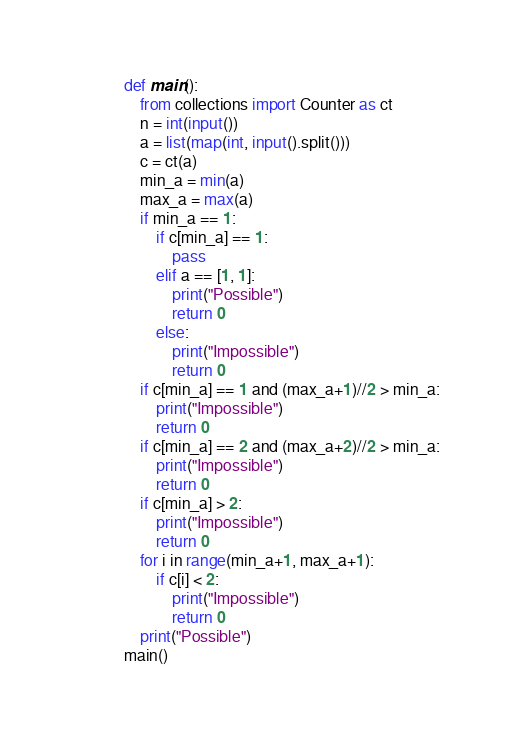Convert code to text. <code><loc_0><loc_0><loc_500><loc_500><_Python_>def main():
    from collections import Counter as ct
    n = int(input())
    a = list(map(int, input().split()))
    c = ct(a)
    min_a = min(a)
    max_a = max(a)
    if min_a == 1:
        if c[min_a] == 1:
            pass
        elif a == [1, 1]:
            print("Possible")
            return 0
        else:
            print("Impossible")
            return 0
    if c[min_a] == 1 and (max_a+1)//2 > min_a:
        print("Impossible")
        return 0
    if c[min_a] == 2 and (max_a+2)//2 > min_a:
        print("Impossible")
        return 0
    if c[min_a] > 2:
        print("Impossible")
        return 0
    for i in range(min_a+1, max_a+1):
        if c[i] < 2:
            print("Impossible")
            return 0
    print("Possible")
main()</code> 